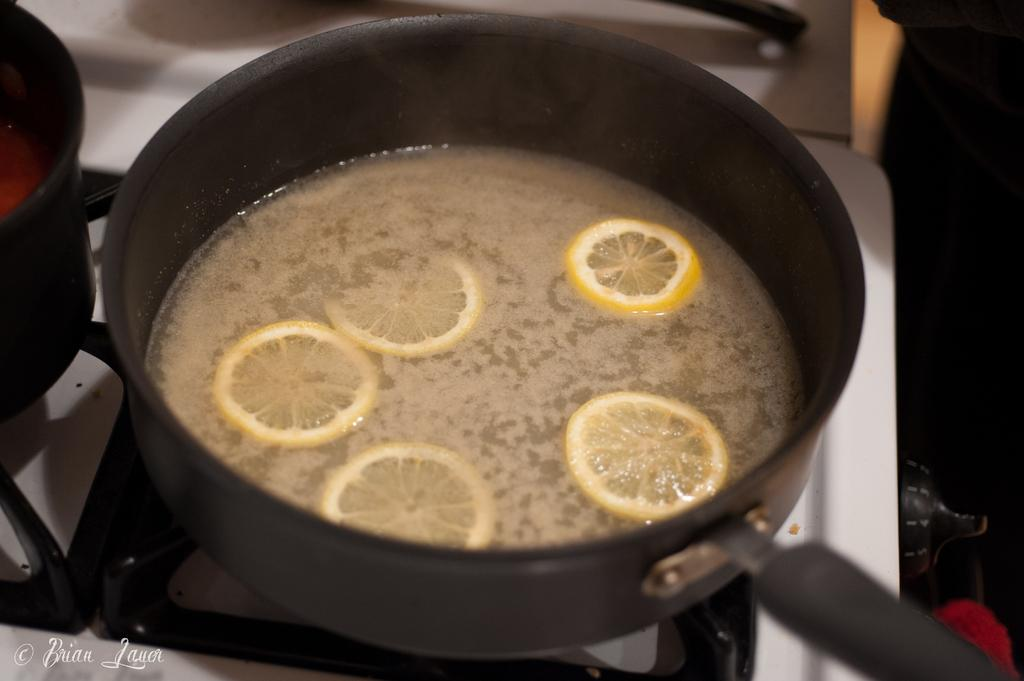What can be seen in the pans in the image? There are food items in pans in the image. What is located at the bottom of the image? There is a stove at the bottom of the image. What advice does the stove give to the food items in the image? The stove does not give advice to the food items in the image; it is an inanimate object. 